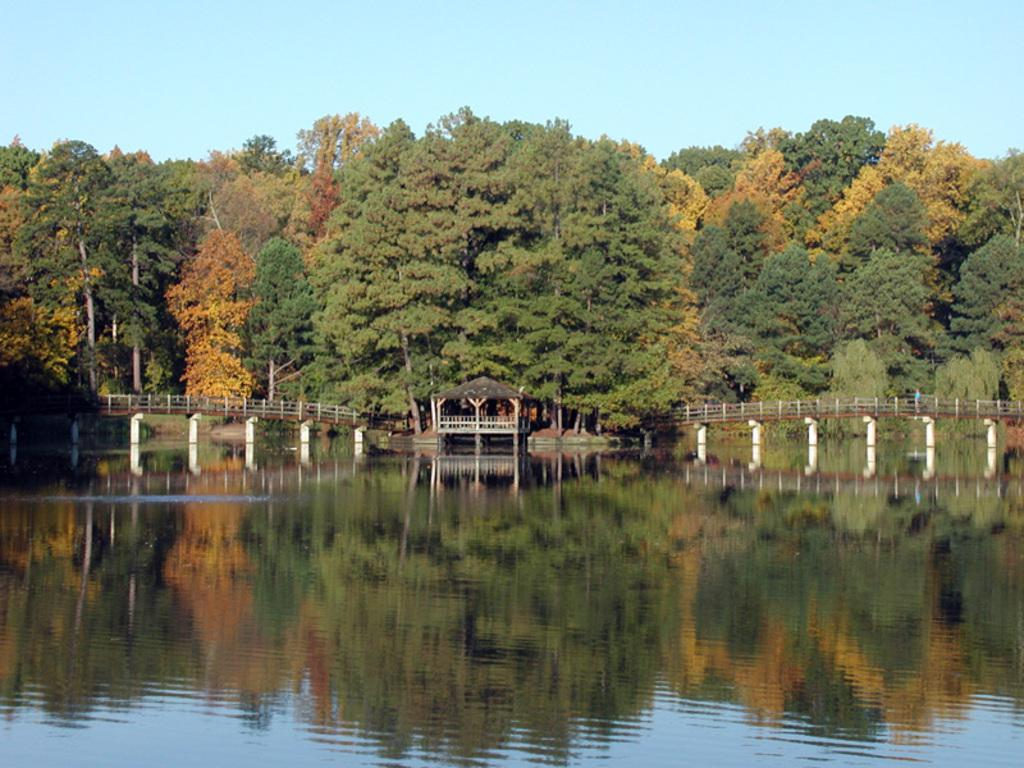What is the main feature in the middle of the picture? There is a river in the middle of the picture. What structure can be seen crossing the river? There is a bridge in the picture. What type of natural environment is visible in the background? There are trees in the background of the picture. How many rakes are being used to maintain the river in the image? There are no rakes visible in the image, and no maintenance activity is taking place. 